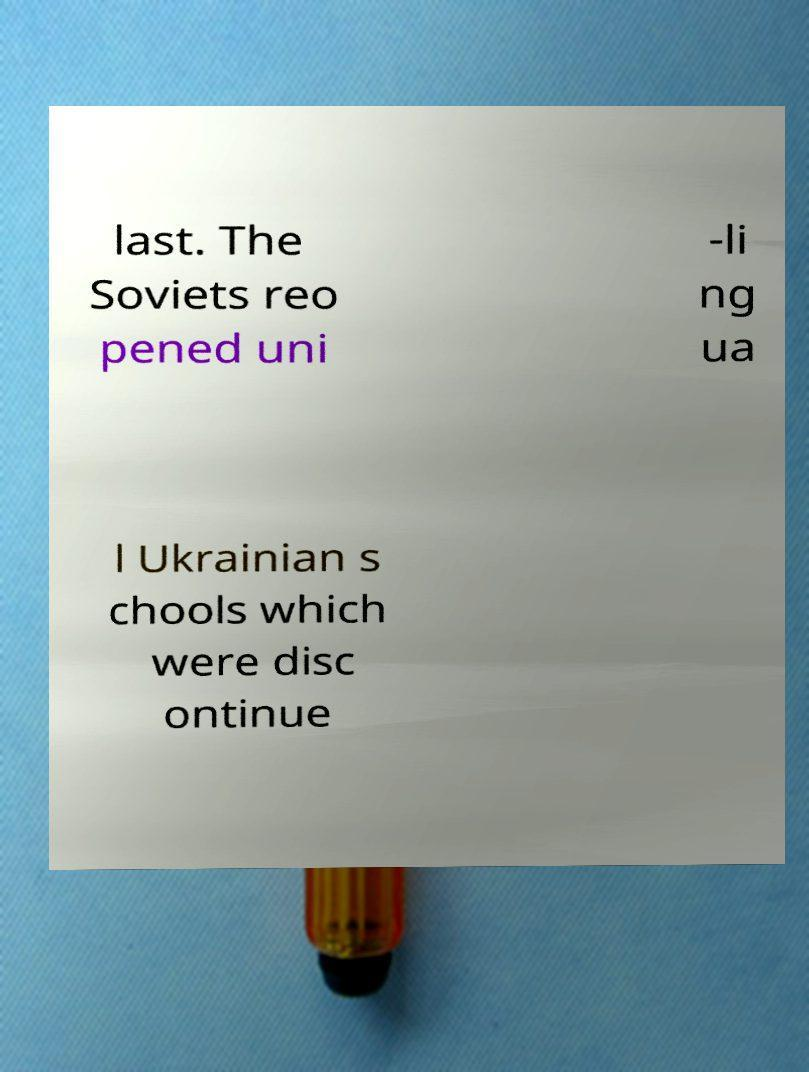I need the written content from this picture converted into text. Can you do that? last. The Soviets reo pened uni -li ng ua l Ukrainian s chools which were disc ontinue 